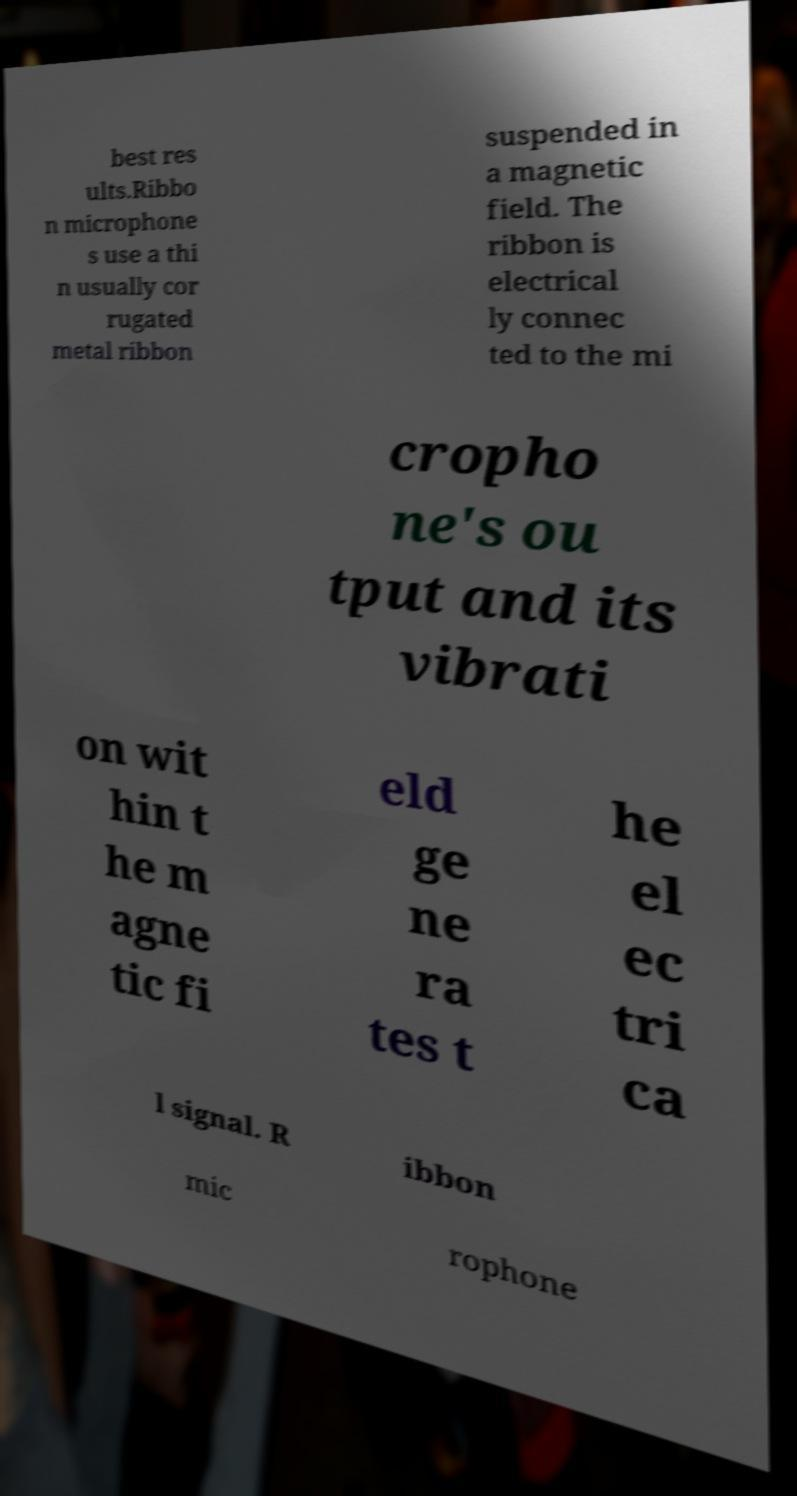Can you accurately transcribe the text from the provided image for me? best res ults.Ribbo n microphone s use a thi n usually cor rugated metal ribbon suspended in a magnetic field. The ribbon is electrical ly connec ted to the mi cropho ne's ou tput and its vibrati on wit hin t he m agne tic fi eld ge ne ra tes t he el ec tri ca l signal. R ibbon mic rophone 